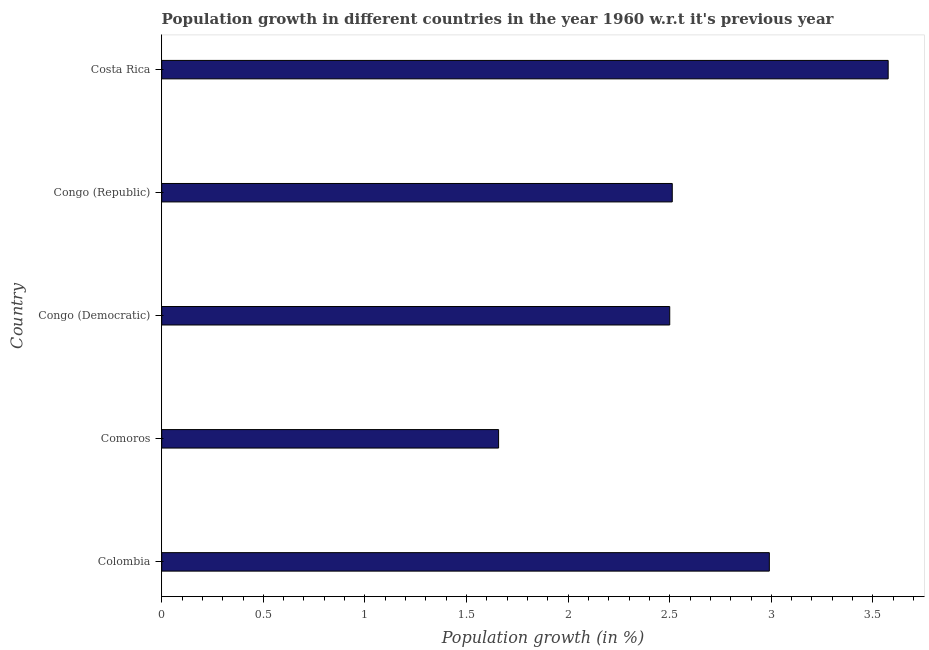Does the graph contain any zero values?
Provide a succinct answer. No. What is the title of the graph?
Make the answer very short. Population growth in different countries in the year 1960 w.r.t it's previous year. What is the label or title of the X-axis?
Make the answer very short. Population growth (in %). What is the label or title of the Y-axis?
Provide a short and direct response. Country. What is the population growth in Colombia?
Your answer should be very brief. 2.99. Across all countries, what is the maximum population growth?
Offer a very short reply. 3.57. Across all countries, what is the minimum population growth?
Your response must be concise. 1.66. In which country was the population growth maximum?
Make the answer very short. Costa Rica. In which country was the population growth minimum?
Offer a terse response. Comoros. What is the sum of the population growth?
Ensure brevity in your answer.  13.24. What is the difference between the population growth in Congo (Republic) and Costa Rica?
Give a very brief answer. -1.06. What is the average population growth per country?
Keep it short and to the point. 2.65. What is the median population growth?
Offer a terse response. 2.51. What is the ratio of the population growth in Congo (Republic) to that in Costa Rica?
Your answer should be compact. 0.7. Is the difference between the population growth in Colombia and Congo (Democratic) greater than the difference between any two countries?
Your answer should be compact. No. What is the difference between the highest and the second highest population growth?
Provide a short and direct response. 0.58. What is the difference between the highest and the lowest population growth?
Offer a terse response. 1.92. In how many countries, is the population growth greater than the average population growth taken over all countries?
Make the answer very short. 2. How many bars are there?
Keep it short and to the point. 5. What is the Population growth (in %) in Colombia?
Keep it short and to the point. 2.99. What is the Population growth (in %) of Comoros?
Provide a succinct answer. 1.66. What is the Population growth (in %) of Congo (Democratic)?
Provide a short and direct response. 2.5. What is the Population growth (in %) in Congo (Republic)?
Offer a terse response. 2.51. What is the Population growth (in %) of Costa Rica?
Provide a succinct answer. 3.57. What is the difference between the Population growth (in %) in Colombia and Comoros?
Provide a short and direct response. 1.33. What is the difference between the Population growth (in %) in Colombia and Congo (Democratic)?
Your response must be concise. 0.49. What is the difference between the Population growth (in %) in Colombia and Congo (Republic)?
Your answer should be compact. 0.48. What is the difference between the Population growth (in %) in Colombia and Costa Rica?
Give a very brief answer. -0.58. What is the difference between the Population growth (in %) in Comoros and Congo (Democratic)?
Keep it short and to the point. -0.84. What is the difference between the Population growth (in %) in Comoros and Congo (Republic)?
Your answer should be very brief. -0.85. What is the difference between the Population growth (in %) in Comoros and Costa Rica?
Keep it short and to the point. -1.92. What is the difference between the Population growth (in %) in Congo (Democratic) and Congo (Republic)?
Provide a short and direct response. -0.01. What is the difference between the Population growth (in %) in Congo (Democratic) and Costa Rica?
Provide a short and direct response. -1.07. What is the difference between the Population growth (in %) in Congo (Republic) and Costa Rica?
Your answer should be compact. -1.06. What is the ratio of the Population growth (in %) in Colombia to that in Comoros?
Your answer should be compact. 1.8. What is the ratio of the Population growth (in %) in Colombia to that in Congo (Democratic)?
Provide a succinct answer. 1.2. What is the ratio of the Population growth (in %) in Colombia to that in Congo (Republic)?
Your answer should be very brief. 1.19. What is the ratio of the Population growth (in %) in Colombia to that in Costa Rica?
Your answer should be very brief. 0.84. What is the ratio of the Population growth (in %) in Comoros to that in Congo (Democratic)?
Keep it short and to the point. 0.66. What is the ratio of the Population growth (in %) in Comoros to that in Congo (Republic)?
Provide a short and direct response. 0.66. What is the ratio of the Population growth (in %) in Comoros to that in Costa Rica?
Your response must be concise. 0.46. What is the ratio of the Population growth (in %) in Congo (Democratic) to that in Congo (Republic)?
Your answer should be compact. 0.99. What is the ratio of the Population growth (in %) in Congo (Democratic) to that in Costa Rica?
Provide a succinct answer. 0.7. What is the ratio of the Population growth (in %) in Congo (Republic) to that in Costa Rica?
Provide a short and direct response. 0.7. 